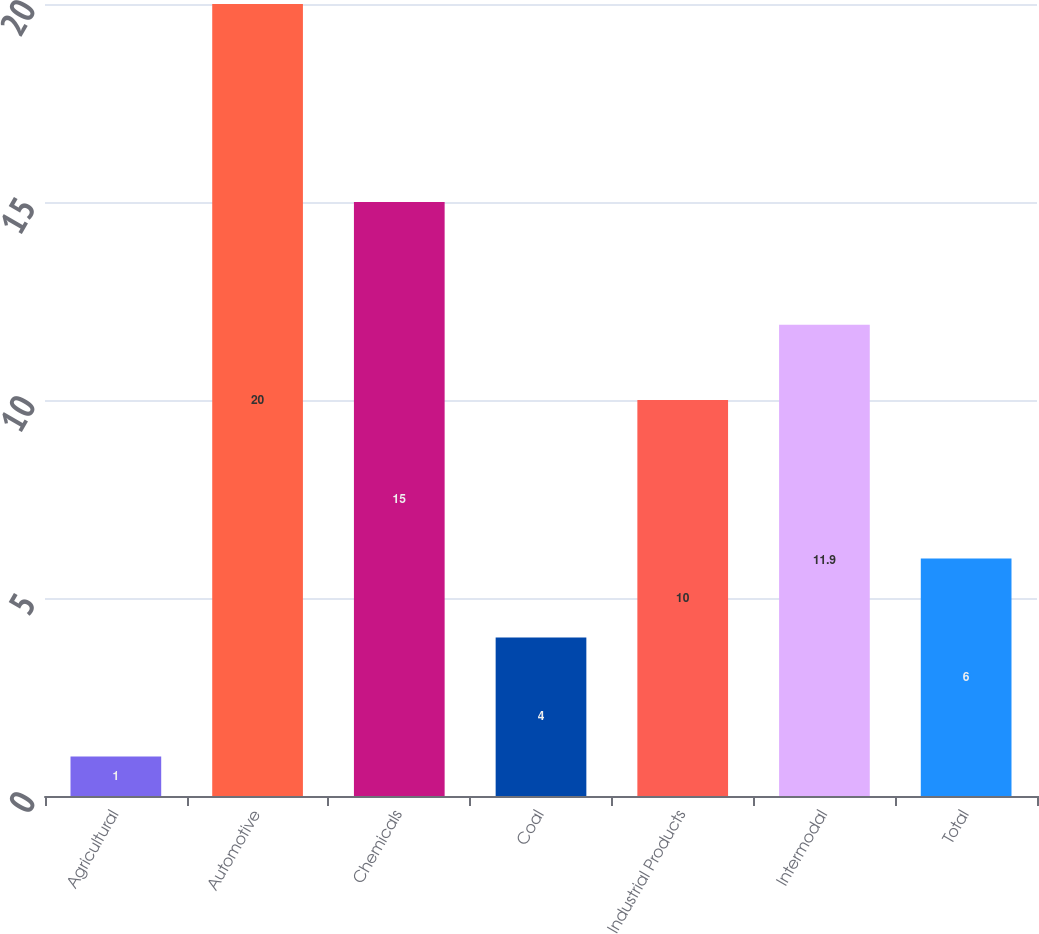Convert chart. <chart><loc_0><loc_0><loc_500><loc_500><bar_chart><fcel>Agricultural<fcel>Automotive<fcel>Chemicals<fcel>Coal<fcel>Industrial Products<fcel>Intermodal<fcel>Total<nl><fcel>1<fcel>20<fcel>15<fcel>4<fcel>10<fcel>11.9<fcel>6<nl></chart> 